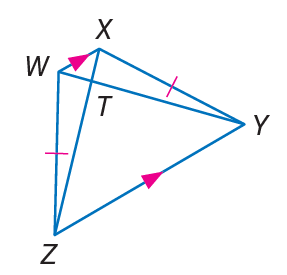Question: Find W T, if Z X = 20 and T Y = 15.
Choices:
A. 5
B. 15
C. 20
D. 35
Answer with the letter. Answer: A 